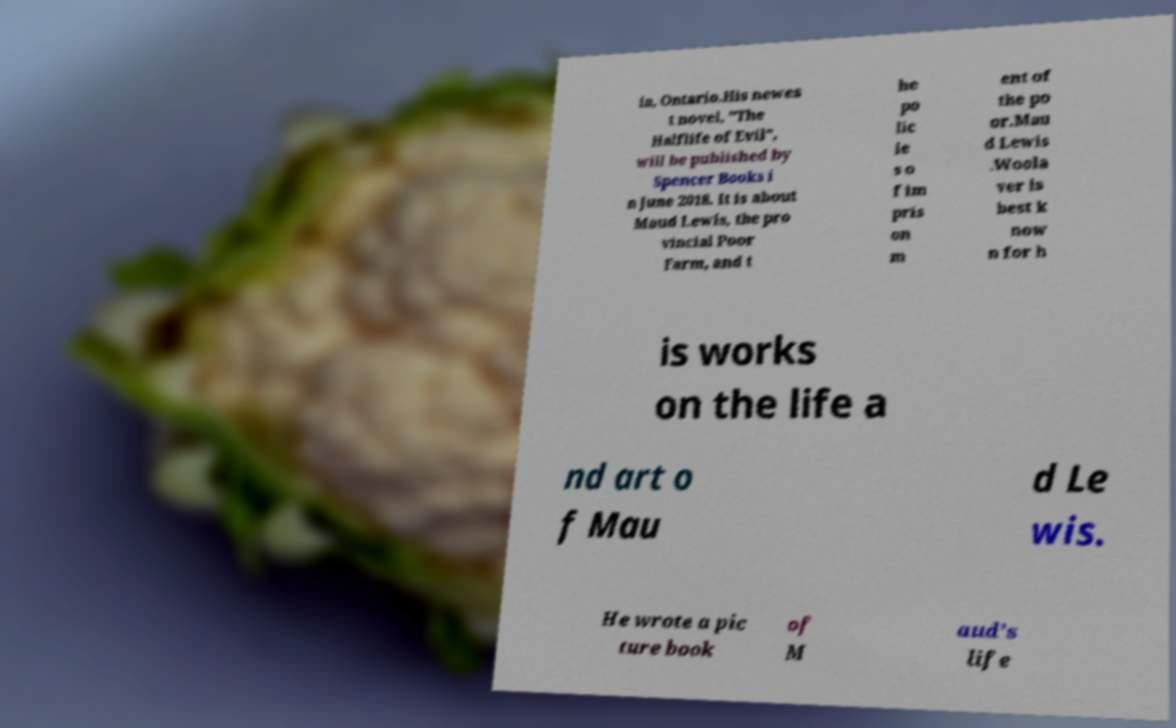Could you extract and type out the text from this image? ia, Ontario.His newes t novel, "The Halflife of Evil", will be published by Spencer Books i n June 2018. It is about Maud Lewis, the pro vincial Poor Farm, and t he po lic ie s o f im pris on m ent of the po or.Mau d Lewis .Woola ver is best k now n for h is works on the life a nd art o f Mau d Le wis. He wrote a pic ture book of M aud’s life 